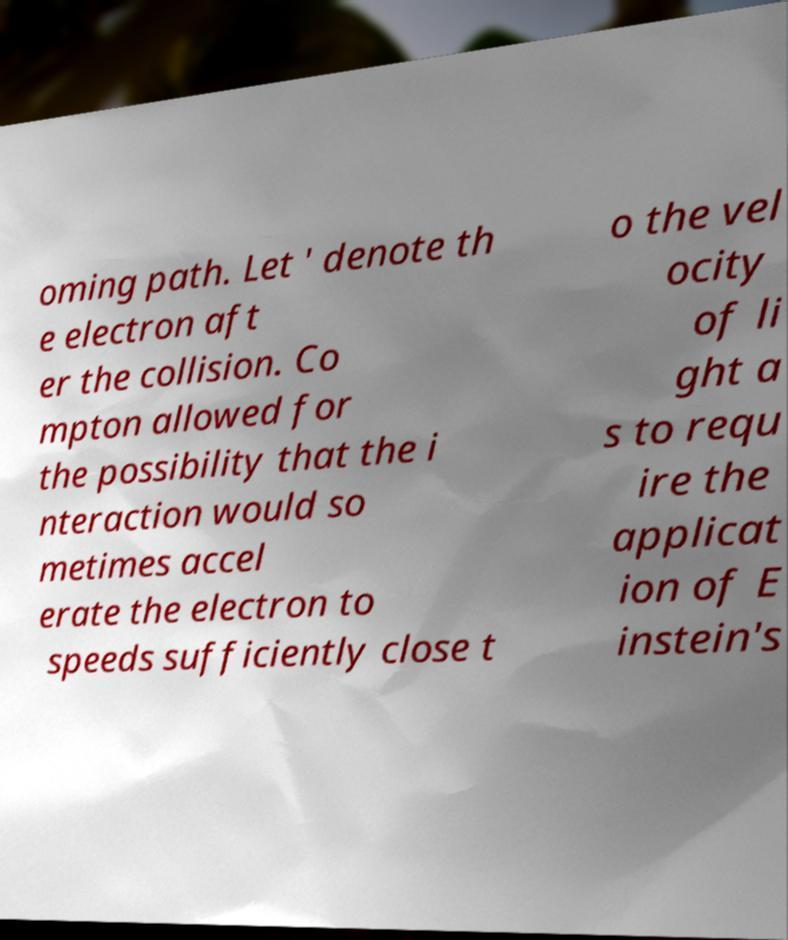Could you assist in decoding the text presented in this image and type it out clearly? oming path. Let ' denote th e electron aft er the collision. Co mpton allowed for the possibility that the i nteraction would so metimes accel erate the electron to speeds sufficiently close t o the vel ocity of li ght a s to requ ire the applicat ion of E instein's 